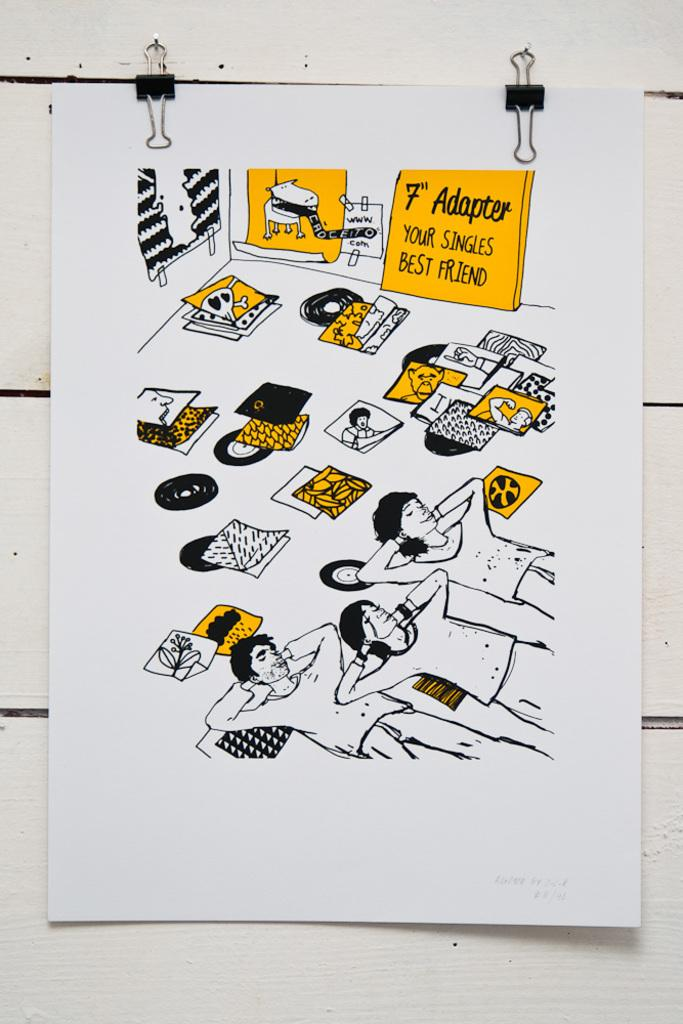<image>
Summarize the visual content of the image. A piece of paper on a wall that states 7 inch adapter, your singles best friend. 